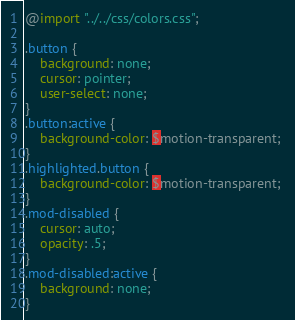Convert code to text. <code><loc_0><loc_0><loc_500><loc_500><_CSS_>@import "../../css/colors.css";

.button {
    background: none;
    cursor: pointer;
    user-select: none;
}
.button:active {
    background-color: $motion-transparent; 
}
.highlighted.button {
    background-color: $motion-transparent; 
}
.mod-disabled {
    cursor: auto;
    opacity: .5;
}
.mod-disabled:active {
    background: none;
}
</code> 